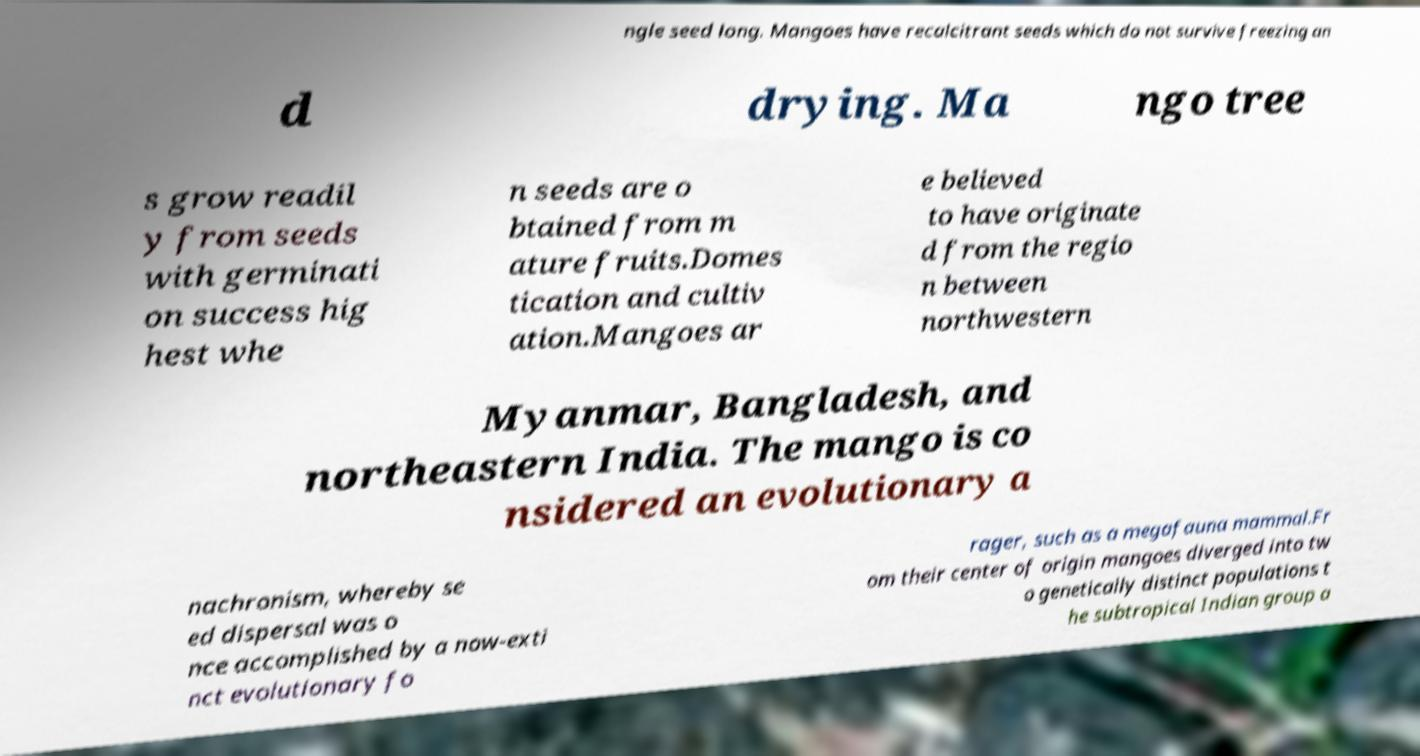Could you assist in decoding the text presented in this image and type it out clearly? ngle seed long. Mangoes have recalcitrant seeds which do not survive freezing an d drying. Ma ngo tree s grow readil y from seeds with germinati on success hig hest whe n seeds are o btained from m ature fruits.Domes tication and cultiv ation.Mangoes ar e believed to have originate d from the regio n between northwestern Myanmar, Bangladesh, and northeastern India. The mango is co nsidered an evolutionary a nachronism, whereby se ed dispersal was o nce accomplished by a now-exti nct evolutionary fo rager, such as a megafauna mammal.Fr om their center of origin mangoes diverged into tw o genetically distinct populations t he subtropical Indian group a 